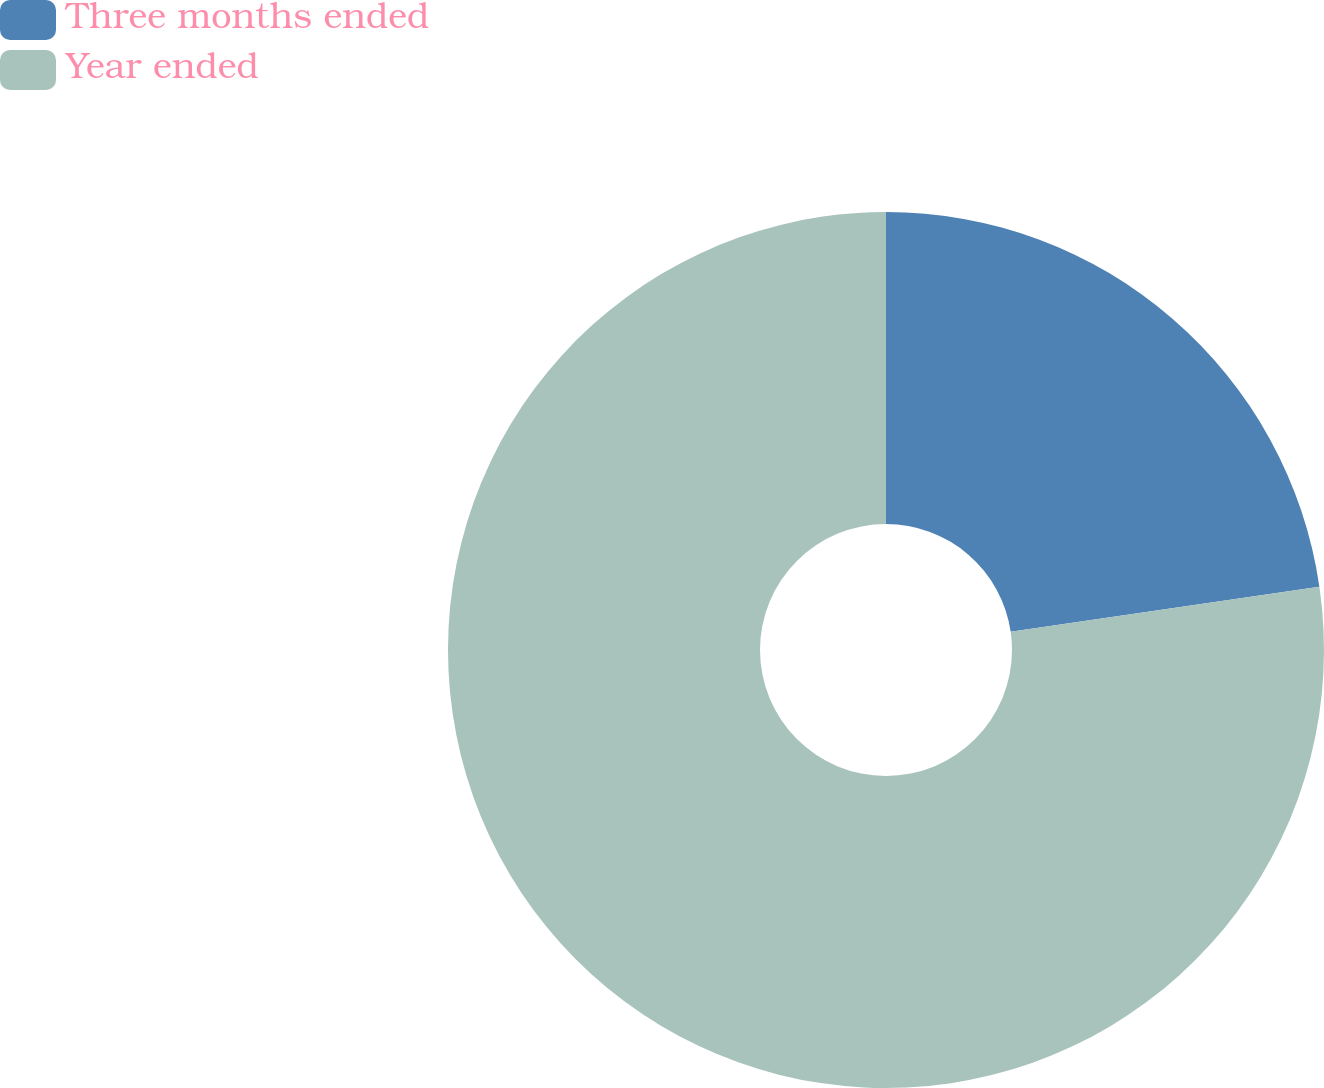Convert chart. <chart><loc_0><loc_0><loc_500><loc_500><pie_chart><fcel>Three months ended<fcel>Year ended<nl><fcel>22.69%<fcel>77.31%<nl></chart> 